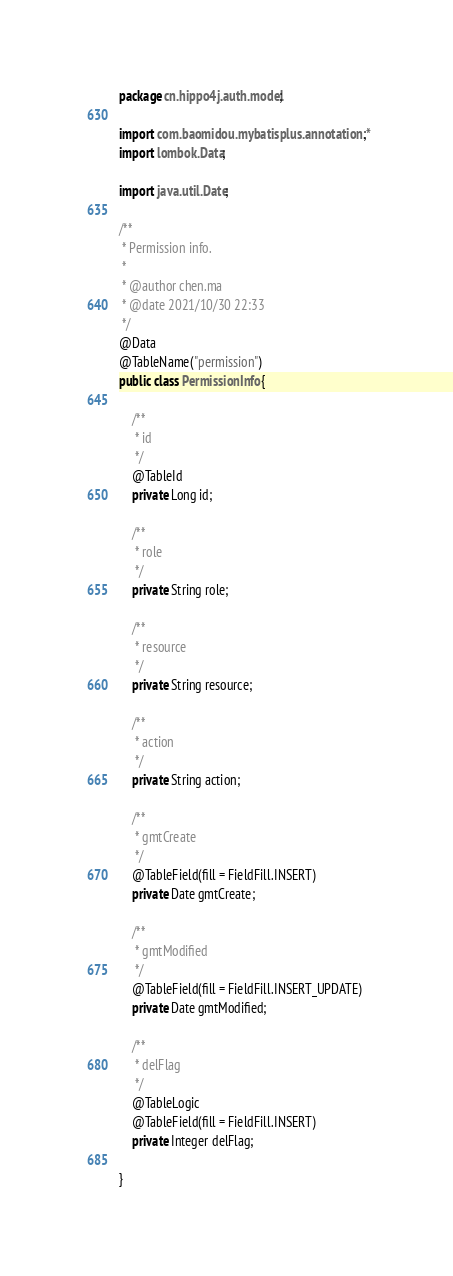Convert code to text. <code><loc_0><loc_0><loc_500><loc_500><_Java_>package cn.hippo4j.auth.model;

import com.baomidou.mybatisplus.annotation.*;
import lombok.Data;

import java.util.Date;

/**
 * Permission info.
 *
 * @author chen.ma
 * @date 2021/10/30 22:33
 */
@Data
@TableName("permission")
public class PermissionInfo {

    /**
     * id
     */
    @TableId
    private Long id;

    /**
     * role
     */
    private String role;

    /**
     * resource
     */
    private String resource;

    /**
     * action
     */
    private String action;

    /**
     * gmtCreate
     */
    @TableField(fill = FieldFill.INSERT)
    private Date gmtCreate;

    /**
     * gmtModified
     */
    @TableField(fill = FieldFill.INSERT_UPDATE)
    private Date gmtModified;

    /**
     * delFlag
     */
    @TableLogic
    @TableField(fill = FieldFill.INSERT)
    private Integer delFlag;

}
</code> 